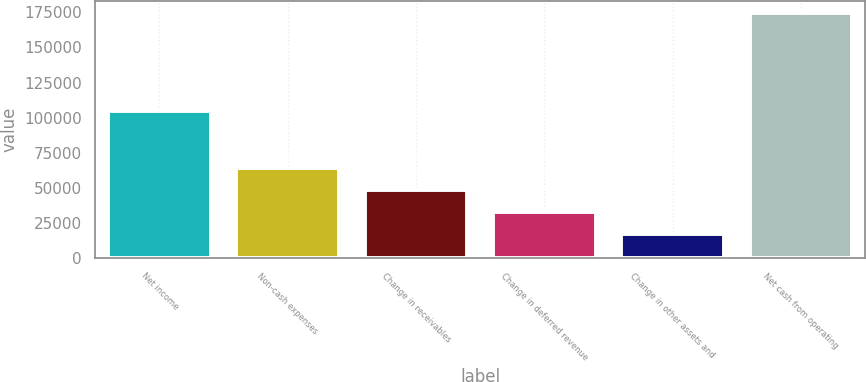Convert chart. <chart><loc_0><loc_0><loc_500><loc_500><bar_chart><fcel>Net income<fcel>Non-cash expenses<fcel>Change in receivables<fcel>Change in deferred revenue<fcel>Change in other assets and<fcel>Net cash from operating<nl><fcel>104681<fcel>64520.6<fcel>48845.4<fcel>33170.2<fcel>17495<fcel>174247<nl></chart> 